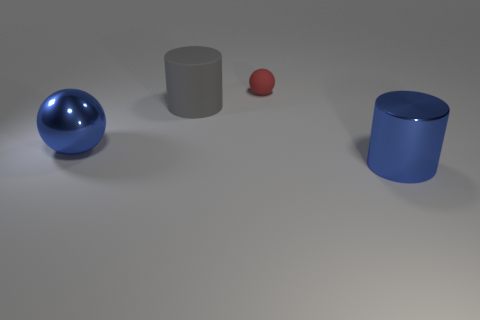Is the material of the big gray cylinder the same as the sphere that is to the right of the large blue metallic sphere? The big gray cylinder and the small sphere to the right of the large blue metallic sphere appear to have different finishes. The cylinder has a matte finish, while the small sphere has a glossy appearance, indicating that they likely have different material properties or surface treatments. 